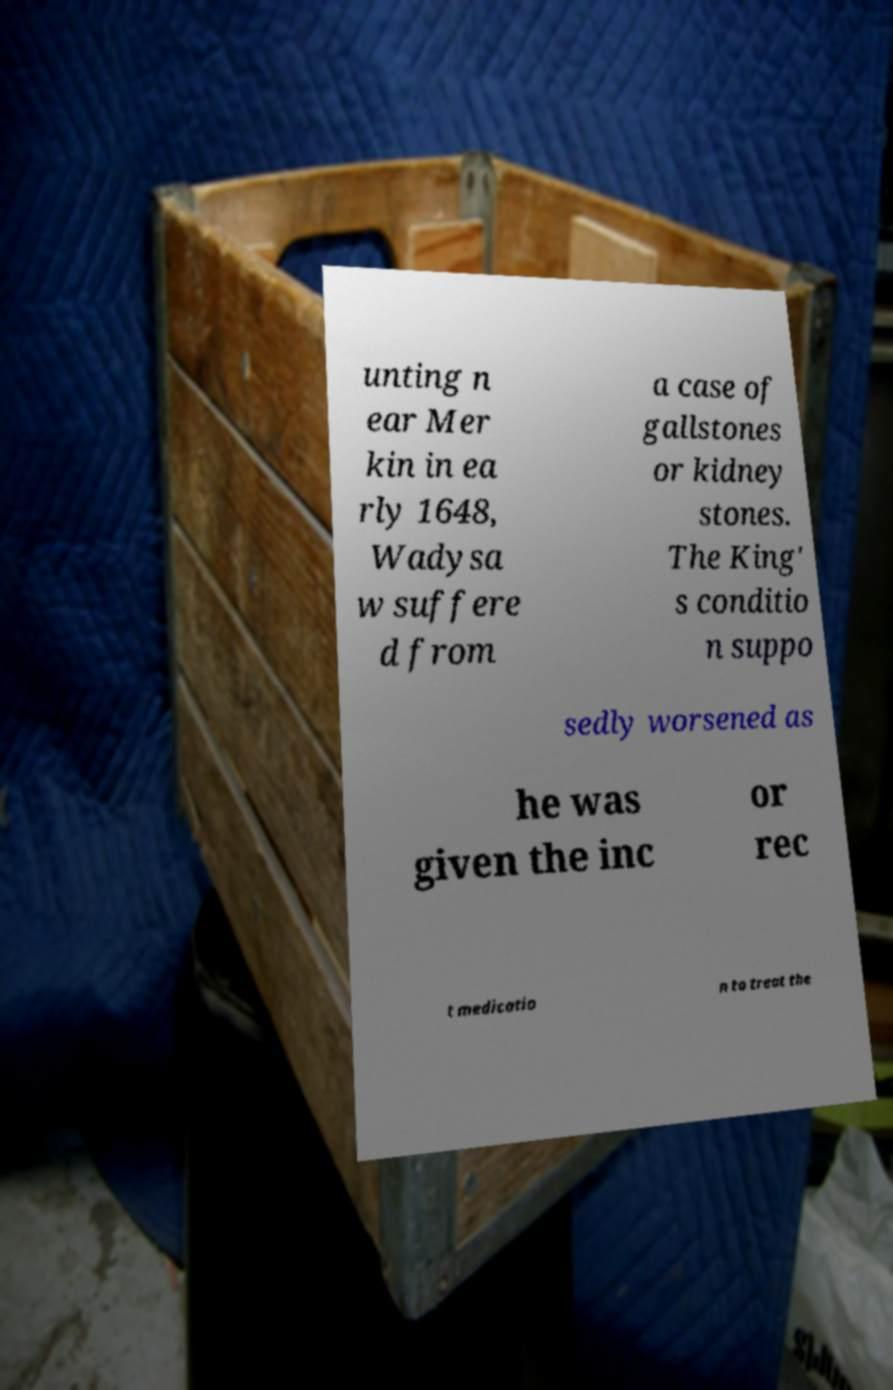What messages or text are displayed in this image? I need them in a readable, typed format. unting n ear Mer kin in ea rly 1648, Wadysa w suffere d from a case of gallstones or kidney stones. The King' s conditio n suppo sedly worsened as he was given the inc or rec t medicatio n to treat the 